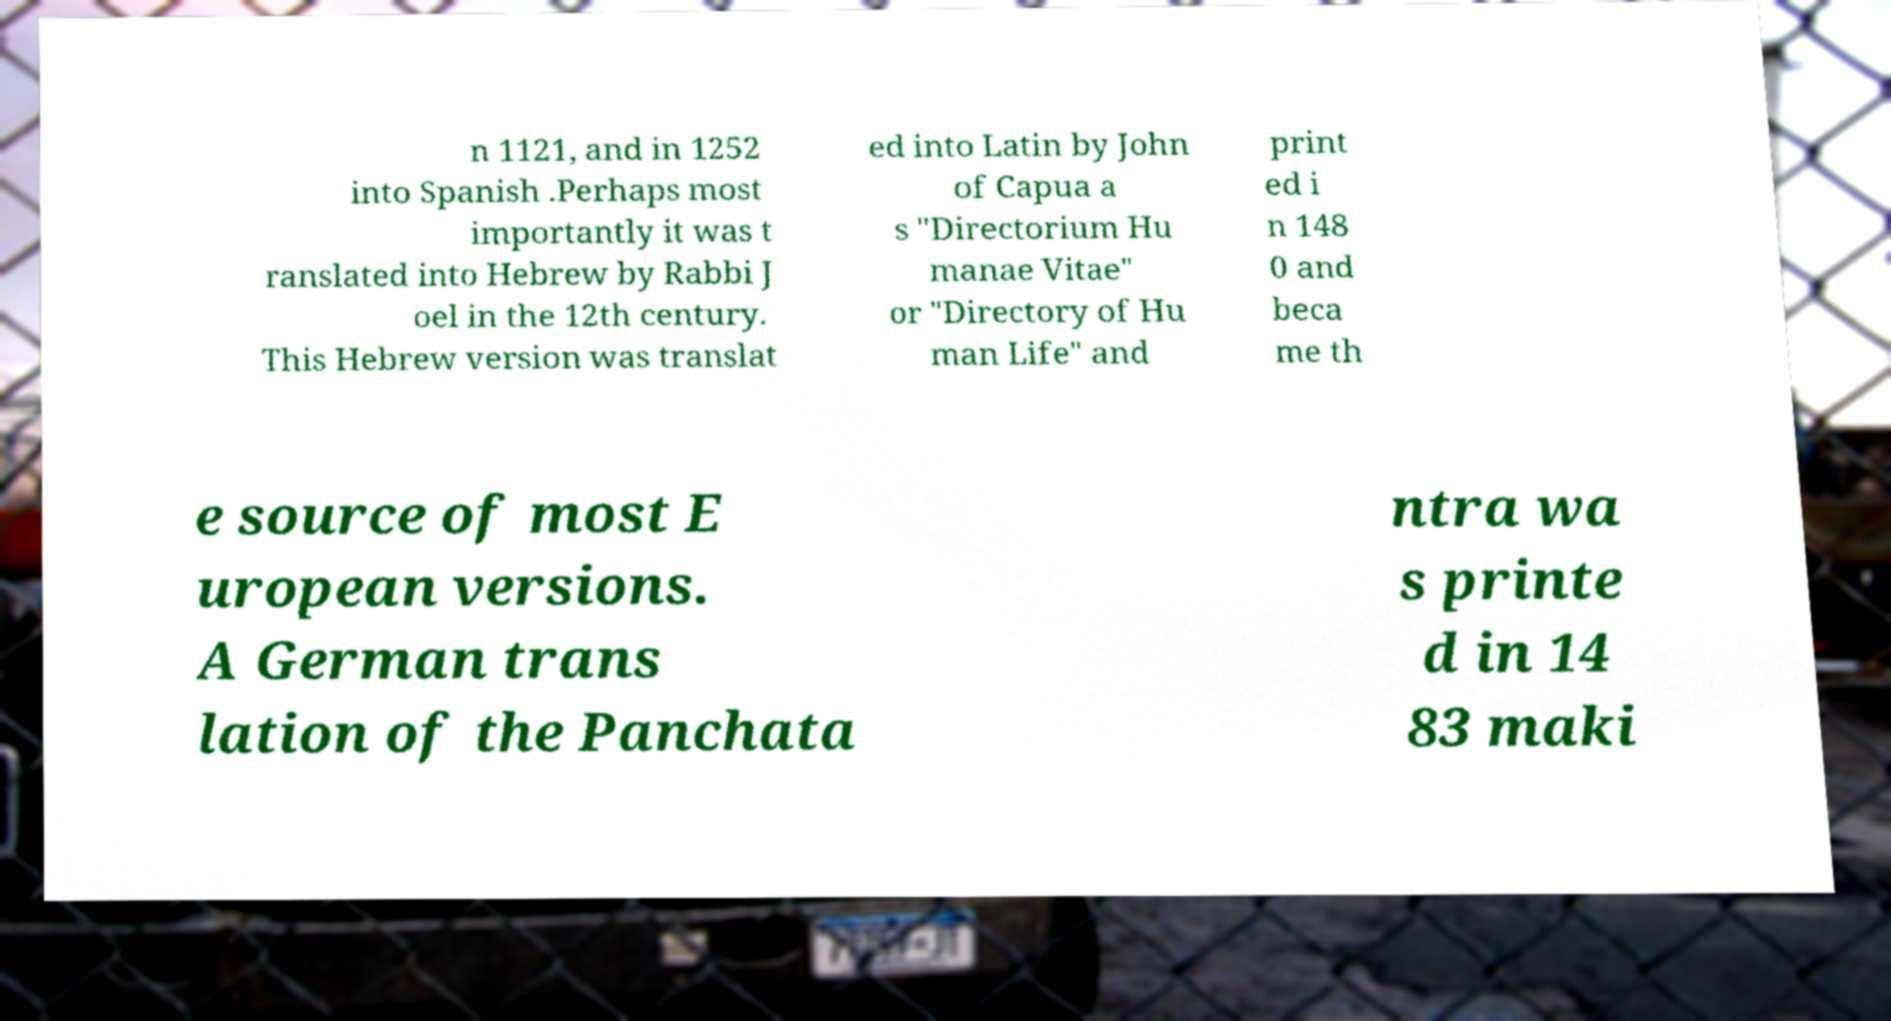Could you assist in decoding the text presented in this image and type it out clearly? n 1121, and in 1252 into Spanish .Perhaps most importantly it was t ranslated into Hebrew by Rabbi J oel in the 12th century. This Hebrew version was translat ed into Latin by John of Capua a s "Directorium Hu manae Vitae" or "Directory of Hu man Life" and print ed i n 148 0 and beca me th e source of most E uropean versions. A German trans lation of the Panchata ntra wa s printe d in 14 83 maki 